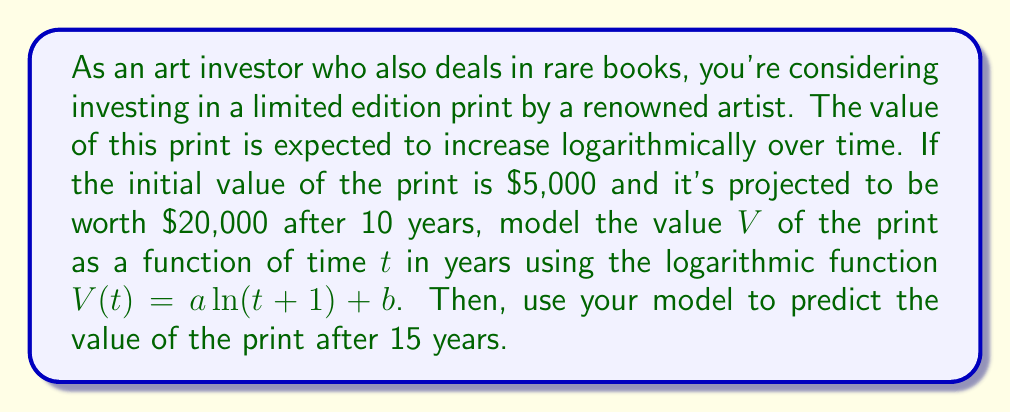Can you answer this question? To solve this problem, we'll follow these steps:

1) We're given that the function has the form $V(t) = a \ln(t+1) + b$. We need to find $a$ and $b$.

2) We know two points on this function:
   At $t=0$, $V(0) = 5000$
   At $t=10$, $V(10) = 20000$

3) Let's use these points to create a system of equations:

   $5000 = a \ln(1) + b$
   $20000 = a \ln(11) + b$

4) Simplify the first equation:
   $5000 = b$ (since $\ln(1) = 0$)

5) Substitute this into the second equation:
   $20000 = a \ln(11) + 5000$

6) Solve for $a$:
   $15000 = a \ln(11)$
   $a = \frac{15000}{\ln(11)} \approx 6213.18$

7) Now we have our function:
   $V(t) = 6213.18 \ln(t+1) + 5000$

8) To find the value after 15 years, we substitute $t=15$:

   $V(15) = 6213.18 \ln(16) + 5000$
          $\approx 6213.18 * 2.77258872 + 5000$
          $\approx 17237.18 + 5000$
          $\approx 22237.18$

Therefore, after 15 years, the print is expected to be worth approximately $22,237.18.
Answer: The value of the print after 15 years is predicted to be approximately $22,237.18. 